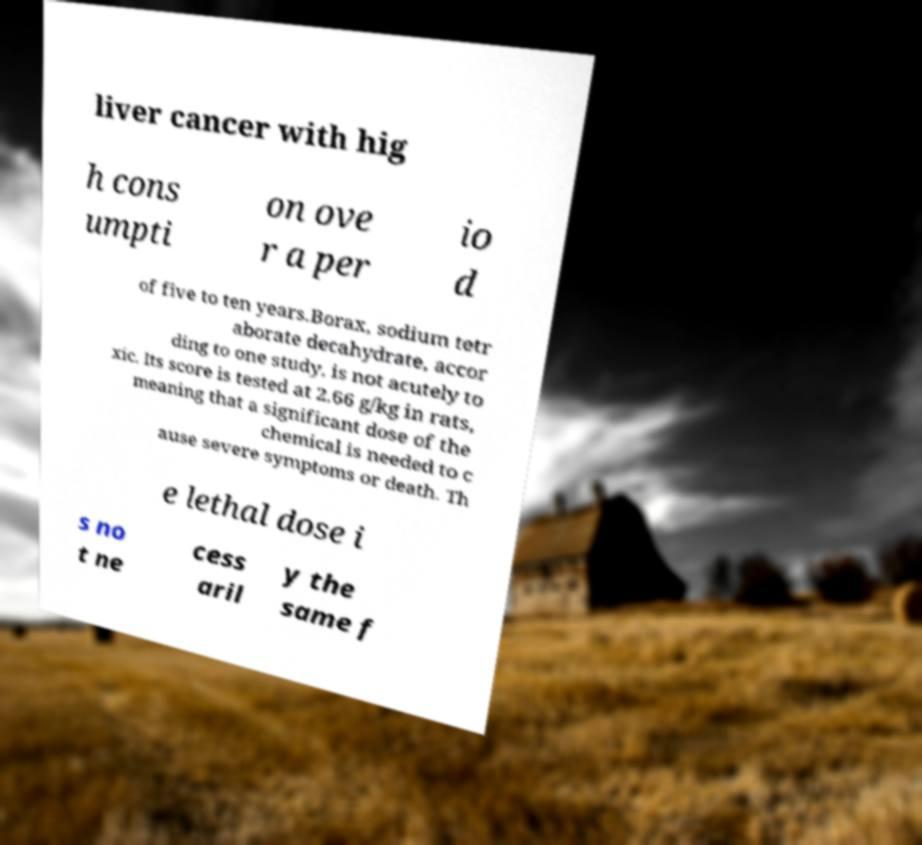There's text embedded in this image that I need extracted. Can you transcribe it verbatim? liver cancer with hig h cons umpti on ove r a per io d of five to ten years.Borax, sodium tetr aborate decahydrate, accor ding to one study, is not acutely to xic. Its score is tested at 2.66 g/kg in rats, meaning that a significant dose of the chemical is needed to c ause severe symptoms or death. Th e lethal dose i s no t ne cess aril y the same f 